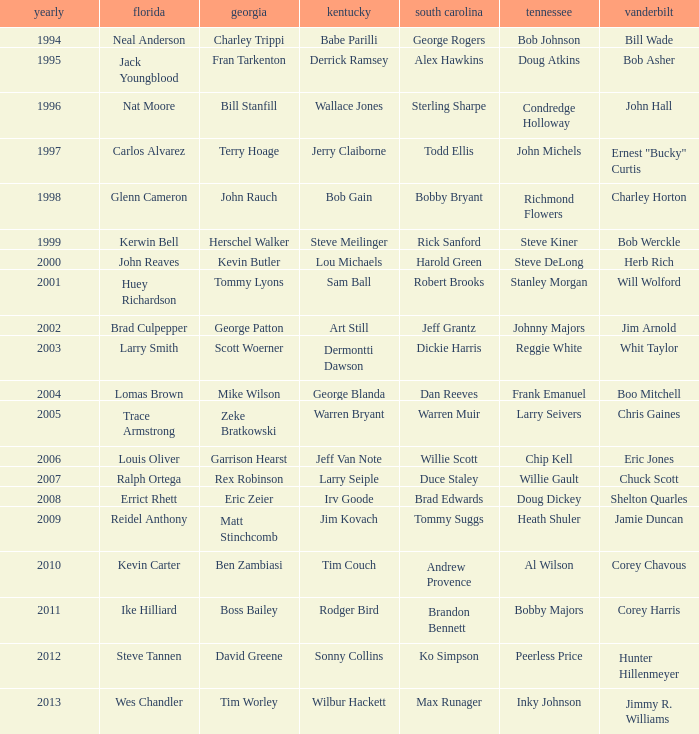What is the total Year of jeff van note ( Kentucky) 2006.0. 